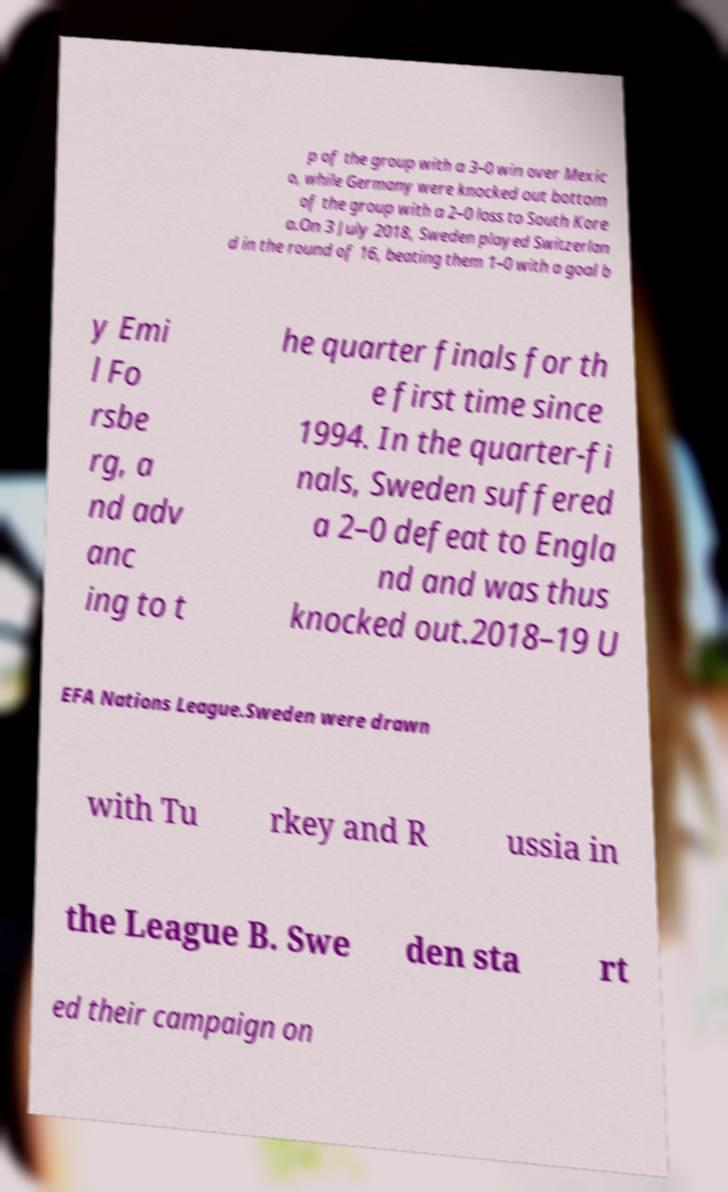Please read and relay the text visible in this image. What does it say? p of the group with a 3–0 win over Mexic o, while Germany were knocked out bottom of the group with a 2–0 loss to South Kore a.On 3 July 2018, Sweden played Switzerlan d in the round of 16, beating them 1–0 with a goal b y Emi l Fo rsbe rg, a nd adv anc ing to t he quarter finals for th e first time since 1994. In the quarter-fi nals, Sweden suffered a 2–0 defeat to Engla nd and was thus knocked out.2018–19 U EFA Nations League.Sweden were drawn with Tu rkey and R ussia in the League B. Swe den sta rt ed their campaign on 